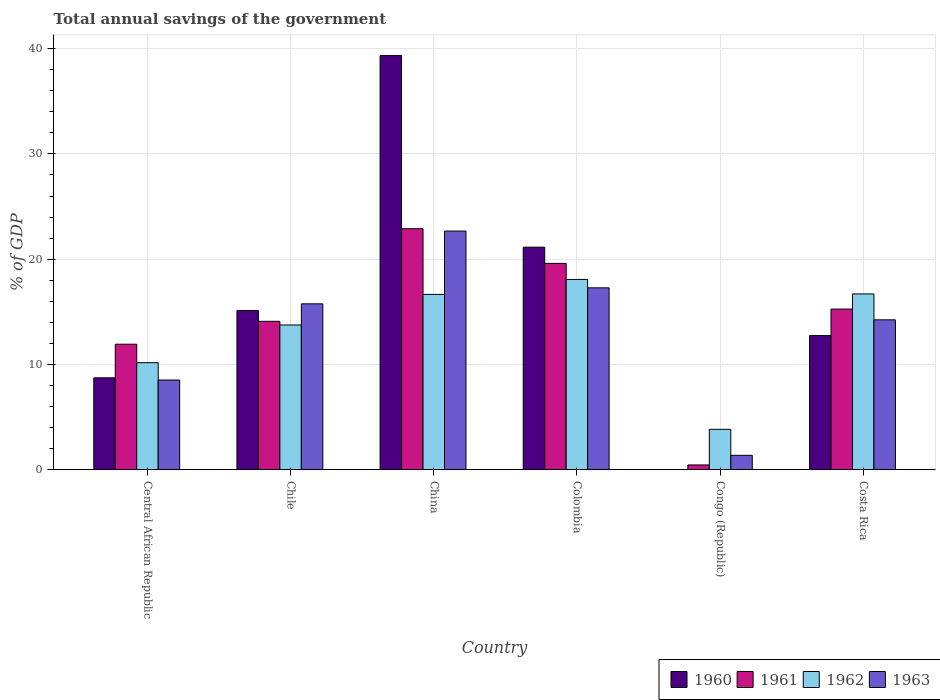How many different coloured bars are there?
Your answer should be compact. 4. How many groups of bars are there?
Your response must be concise. 6. Are the number of bars per tick equal to the number of legend labels?
Offer a terse response. No. How many bars are there on the 6th tick from the left?
Provide a succinct answer. 4. How many bars are there on the 3rd tick from the right?
Keep it short and to the point. 4. Across all countries, what is the maximum total annual savings of the government in 1961?
Keep it short and to the point. 22.89. Across all countries, what is the minimum total annual savings of the government in 1962?
Make the answer very short. 3.84. In which country was the total annual savings of the government in 1963 maximum?
Your response must be concise. China. What is the total total annual savings of the government in 1960 in the graph?
Keep it short and to the point. 97.07. What is the difference between the total annual savings of the government in 1962 in Colombia and that in Costa Rica?
Make the answer very short. 1.38. What is the difference between the total annual savings of the government in 1962 in Costa Rica and the total annual savings of the government in 1960 in Colombia?
Offer a terse response. -4.44. What is the average total annual savings of the government in 1961 per country?
Give a very brief answer. 14.04. What is the difference between the total annual savings of the government of/in 1963 and total annual savings of the government of/in 1961 in Central African Republic?
Give a very brief answer. -3.4. What is the ratio of the total annual savings of the government in 1963 in Central African Republic to that in Costa Rica?
Ensure brevity in your answer.  0.6. Is the difference between the total annual savings of the government in 1963 in Chile and Costa Rica greater than the difference between the total annual savings of the government in 1961 in Chile and Costa Rica?
Give a very brief answer. Yes. What is the difference between the highest and the second highest total annual savings of the government in 1962?
Offer a very short reply. 0.04. What is the difference between the highest and the lowest total annual savings of the government in 1963?
Make the answer very short. 21.3. In how many countries, is the total annual savings of the government in 1963 greater than the average total annual savings of the government in 1963 taken over all countries?
Your answer should be compact. 4. Is it the case that in every country, the sum of the total annual savings of the government in 1961 and total annual savings of the government in 1962 is greater than the total annual savings of the government in 1960?
Provide a succinct answer. Yes. How many countries are there in the graph?
Your answer should be compact. 6. What is the difference between two consecutive major ticks on the Y-axis?
Offer a very short reply. 10. How are the legend labels stacked?
Make the answer very short. Horizontal. What is the title of the graph?
Offer a very short reply. Total annual savings of the government. Does "2007" appear as one of the legend labels in the graph?
Provide a short and direct response. No. What is the label or title of the Y-axis?
Offer a very short reply. % of GDP. What is the % of GDP in 1960 in Central African Republic?
Provide a succinct answer. 8.73. What is the % of GDP in 1961 in Central African Republic?
Your answer should be very brief. 11.92. What is the % of GDP in 1962 in Central African Republic?
Offer a very short reply. 10.16. What is the % of GDP in 1963 in Central African Republic?
Your answer should be compact. 8.52. What is the % of GDP of 1960 in Chile?
Provide a succinct answer. 15.12. What is the % of GDP of 1961 in Chile?
Your answer should be very brief. 14.1. What is the % of GDP in 1962 in Chile?
Provide a succinct answer. 13.75. What is the % of GDP of 1963 in Chile?
Offer a terse response. 15.76. What is the % of GDP of 1960 in China?
Your answer should be very brief. 39.34. What is the % of GDP in 1961 in China?
Your answer should be very brief. 22.89. What is the % of GDP of 1962 in China?
Ensure brevity in your answer.  16.65. What is the % of GDP in 1963 in China?
Ensure brevity in your answer.  22.67. What is the % of GDP of 1960 in Colombia?
Make the answer very short. 21.14. What is the % of GDP in 1961 in Colombia?
Your answer should be very brief. 19.6. What is the % of GDP of 1962 in Colombia?
Offer a very short reply. 18.08. What is the % of GDP of 1963 in Colombia?
Offer a very short reply. 17.28. What is the % of GDP of 1961 in Congo (Republic)?
Make the answer very short. 0.45. What is the % of GDP of 1962 in Congo (Republic)?
Make the answer very short. 3.84. What is the % of GDP in 1963 in Congo (Republic)?
Offer a terse response. 1.37. What is the % of GDP in 1960 in Costa Rica?
Ensure brevity in your answer.  12.74. What is the % of GDP of 1961 in Costa Rica?
Provide a succinct answer. 15.26. What is the % of GDP of 1962 in Costa Rica?
Give a very brief answer. 16.7. What is the % of GDP of 1963 in Costa Rica?
Your answer should be very brief. 14.24. Across all countries, what is the maximum % of GDP in 1960?
Ensure brevity in your answer.  39.34. Across all countries, what is the maximum % of GDP of 1961?
Provide a short and direct response. 22.89. Across all countries, what is the maximum % of GDP of 1962?
Give a very brief answer. 18.08. Across all countries, what is the maximum % of GDP of 1963?
Keep it short and to the point. 22.67. Across all countries, what is the minimum % of GDP in 1961?
Give a very brief answer. 0.45. Across all countries, what is the minimum % of GDP of 1962?
Provide a short and direct response. 3.84. Across all countries, what is the minimum % of GDP of 1963?
Your response must be concise. 1.37. What is the total % of GDP of 1960 in the graph?
Your answer should be compact. 97.07. What is the total % of GDP of 1961 in the graph?
Offer a terse response. 84.22. What is the total % of GDP of 1962 in the graph?
Keep it short and to the point. 79.17. What is the total % of GDP of 1963 in the graph?
Provide a succinct answer. 79.83. What is the difference between the % of GDP in 1960 in Central African Republic and that in Chile?
Give a very brief answer. -6.39. What is the difference between the % of GDP of 1961 in Central African Republic and that in Chile?
Offer a very short reply. -2.18. What is the difference between the % of GDP of 1962 in Central African Republic and that in Chile?
Give a very brief answer. -3.58. What is the difference between the % of GDP in 1963 in Central African Republic and that in Chile?
Provide a short and direct response. -7.24. What is the difference between the % of GDP in 1960 in Central African Republic and that in China?
Give a very brief answer. -30.61. What is the difference between the % of GDP of 1961 in Central African Republic and that in China?
Provide a succinct answer. -10.97. What is the difference between the % of GDP of 1962 in Central African Republic and that in China?
Your answer should be compact. -6.49. What is the difference between the % of GDP of 1963 in Central African Republic and that in China?
Offer a terse response. -14.15. What is the difference between the % of GDP in 1960 in Central African Republic and that in Colombia?
Your response must be concise. -12.41. What is the difference between the % of GDP in 1961 in Central African Republic and that in Colombia?
Your response must be concise. -7.68. What is the difference between the % of GDP in 1962 in Central African Republic and that in Colombia?
Keep it short and to the point. -7.91. What is the difference between the % of GDP of 1963 in Central African Republic and that in Colombia?
Ensure brevity in your answer.  -8.76. What is the difference between the % of GDP of 1961 in Central African Republic and that in Congo (Republic)?
Your answer should be very brief. 11.47. What is the difference between the % of GDP in 1962 in Central African Republic and that in Congo (Republic)?
Provide a short and direct response. 6.33. What is the difference between the % of GDP in 1963 in Central African Republic and that in Congo (Republic)?
Offer a very short reply. 7.15. What is the difference between the % of GDP of 1960 in Central African Republic and that in Costa Rica?
Provide a succinct answer. -4.01. What is the difference between the % of GDP in 1961 in Central African Republic and that in Costa Rica?
Provide a short and direct response. -3.34. What is the difference between the % of GDP in 1962 in Central African Republic and that in Costa Rica?
Offer a terse response. -6.53. What is the difference between the % of GDP in 1963 in Central African Republic and that in Costa Rica?
Your response must be concise. -5.72. What is the difference between the % of GDP of 1960 in Chile and that in China?
Ensure brevity in your answer.  -24.22. What is the difference between the % of GDP in 1961 in Chile and that in China?
Provide a short and direct response. -8.8. What is the difference between the % of GDP in 1962 in Chile and that in China?
Offer a very short reply. -2.91. What is the difference between the % of GDP in 1963 in Chile and that in China?
Make the answer very short. -6.91. What is the difference between the % of GDP in 1960 in Chile and that in Colombia?
Your answer should be compact. -6.02. What is the difference between the % of GDP in 1961 in Chile and that in Colombia?
Provide a succinct answer. -5.5. What is the difference between the % of GDP of 1962 in Chile and that in Colombia?
Ensure brevity in your answer.  -4.33. What is the difference between the % of GDP of 1963 in Chile and that in Colombia?
Provide a short and direct response. -1.52. What is the difference between the % of GDP of 1961 in Chile and that in Congo (Republic)?
Your answer should be compact. 13.64. What is the difference between the % of GDP in 1962 in Chile and that in Congo (Republic)?
Provide a succinct answer. 9.91. What is the difference between the % of GDP of 1963 in Chile and that in Congo (Republic)?
Give a very brief answer. 14.39. What is the difference between the % of GDP of 1960 in Chile and that in Costa Rica?
Ensure brevity in your answer.  2.38. What is the difference between the % of GDP of 1961 in Chile and that in Costa Rica?
Make the answer very short. -1.16. What is the difference between the % of GDP in 1962 in Chile and that in Costa Rica?
Give a very brief answer. -2.95. What is the difference between the % of GDP of 1963 in Chile and that in Costa Rica?
Provide a succinct answer. 1.52. What is the difference between the % of GDP of 1960 in China and that in Colombia?
Make the answer very short. 18.2. What is the difference between the % of GDP of 1961 in China and that in Colombia?
Make the answer very short. 3.29. What is the difference between the % of GDP in 1962 in China and that in Colombia?
Your response must be concise. -1.42. What is the difference between the % of GDP in 1963 in China and that in Colombia?
Your response must be concise. 5.39. What is the difference between the % of GDP of 1961 in China and that in Congo (Republic)?
Offer a terse response. 22.44. What is the difference between the % of GDP in 1962 in China and that in Congo (Republic)?
Offer a terse response. 12.82. What is the difference between the % of GDP in 1963 in China and that in Congo (Republic)?
Provide a succinct answer. 21.3. What is the difference between the % of GDP of 1960 in China and that in Costa Rica?
Offer a very short reply. 26.6. What is the difference between the % of GDP of 1961 in China and that in Costa Rica?
Your answer should be very brief. 7.63. What is the difference between the % of GDP of 1962 in China and that in Costa Rica?
Ensure brevity in your answer.  -0.04. What is the difference between the % of GDP of 1963 in China and that in Costa Rica?
Keep it short and to the point. 8.43. What is the difference between the % of GDP in 1961 in Colombia and that in Congo (Republic)?
Offer a very short reply. 19.15. What is the difference between the % of GDP in 1962 in Colombia and that in Congo (Republic)?
Make the answer very short. 14.24. What is the difference between the % of GDP of 1963 in Colombia and that in Congo (Republic)?
Provide a short and direct response. 15.91. What is the difference between the % of GDP of 1960 in Colombia and that in Costa Rica?
Your answer should be compact. 8.4. What is the difference between the % of GDP of 1961 in Colombia and that in Costa Rica?
Offer a terse response. 4.34. What is the difference between the % of GDP in 1962 in Colombia and that in Costa Rica?
Provide a succinct answer. 1.38. What is the difference between the % of GDP of 1963 in Colombia and that in Costa Rica?
Provide a succinct answer. 3.04. What is the difference between the % of GDP in 1961 in Congo (Republic) and that in Costa Rica?
Provide a succinct answer. -14.81. What is the difference between the % of GDP in 1962 in Congo (Republic) and that in Costa Rica?
Your answer should be very brief. -12.86. What is the difference between the % of GDP of 1963 in Congo (Republic) and that in Costa Rica?
Provide a short and direct response. -12.87. What is the difference between the % of GDP of 1960 in Central African Republic and the % of GDP of 1961 in Chile?
Provide a succinct answer. -5.37. What is the difference between the % of GDP of 1960 in Central African Republic and the % of GDP of 1962 in Chile?
Offer a very short reply. -5.02. What is the difference between the % of GDP in 1960 in Central African Republic and the % of GDP in 1963 in Chile?
Your response must be concise. -7.03. What is the difference between the % of GDP of 1961 in Central African Republic and the % of GDP of 1962 in Chile?
Give a very brief answer. -1.83. What is the difference between the % of GDP in 1961 in Central African Republic and the % of GDP in 1963 in Chile?
Make the answer very short. -3.84. What is the difference between the % of GDP of 1962 in Central African Republic and the % of GDP of 1963 in Chile?
Offer a terse response. -5.59. What is the difference between the % of GDP in 1960 in Central African Republic and the % of GDP in 1961 in China?
Provide a short and direct response. -14.17. What is the difference between the % of GDP of 1960 in Central African Republic and the % of GDP of 1962 in China?
Provide a succinct answer. -7.93. What is the difference between the % of GDP of 1960 in Central African Republic and the % of GDP of 1963 in China?
Provide a short and direct response. -13.94. What is the difference between the % of GDP in 1961 in Central African Republic and the % of GDP in 1962 in China?
Your response must be concise. -4.73. What is the difference between the % of GDP of 1961 in Central African Republic and the % of GDP of 1963 in China?
Provide a succinct answer. -10.75. What is the difference between the % of GDP of 1962 in Central African Republic and the % of GDP of 1963 in China?
Make the answer very short. -12.51. What is the difference between the % of GDP in 1960 in Central African Republic and the % of GDP in 1961 in Colombia?
Your answer should be compact. -10.87. What is the difference between the % of GDP of 1960 in Central African Republic and the % of GDP of 1962 in Colombia?
Keep it short and to the point. -9.35. What is the difference between the % of GDP in 1960 in Central African Republic and the % of GDP in 1963 in Colombia?
Make the answer very short. -8.55. What is the difference between the % of GDP in 1961 in Central African Republic and the % of GDP in 1962 in Colombia?
Give a very brief answer. -6.15. What is the difference between the % of GDP in 1961 in Central African Republic and the % of GDP in 1963 in Colombia?
Offer a terse response. -5.36. What is the difference between the % of GDP in 1962 in Central African Republic and the % of GDP in 1963 in Colombia?
Provide a short and direct response. -7.11. What is the difference between the % of GDP of 1960 in Central African Republic and the % of GDP of 1961 in Congo (Republic)?
Offer a terse response. 8.28. What is the difference between the % of GDP of 1960 in Central African Republic and the % of GDP of 1962 in Congo (Republic)?
Provide a succinct answer. 4.89. What is the difference between the % of GDP in 1960 in Central African Republic and the % of GDP in 1963 in Congo (Republic)?
Your answer should be very brief. 7.36. What is the difference between the % of GDP of 1961 in Central African Republic and the % of GDP of 1962 in Congo (Republic)?
Keep it short and to the point. 8.08. What is the difference between the % of GDP of 1961 in Central African Republic and the % of GDP of 1963 in Congo (Republic)?
Your response must be concise. 10.55. What is the difference between the % of GDP in 1962 in Central African Republic and the % of GDP in 1963 in Congo (Republic)?
Offer a very short reply. 8.8. What is the difference between the % of GDP in 1960 in Central African Republic and the % of GDP in 1961 in Costa Rica?
Keep it short and to the point. -6.53. What is the difference between the % of GDP of 1960 in Central African Republic and the % of GDP of 1962 in Costa Rica?
Provide a short and direct response. -7.97. What is the difference between the % of GDP of 1960 in Central African Republic and the % of GDP of 1963 in Costa Rica?
Give a very brief answer. -5.51. What is the difference between the % of GDP in 1961 in Central African Republic and the % of GDP in 1962 in Costa Rica?
Ensure brevity in your answer.  -4.78. What is the difference between the % of GDP of 1961 in Central African Republic and the % of GDP of 1963 in Costa Rica?
Offer a terse response. -2.32. What is the difference between the % of GDP in 1962 in Central African Republic and the % of GDP in 1963 in Costa Rica?
Offer a terse response. -4.07. What is the difference between the % of GDP of 1960 in Chile and the % of GDP of 1961 in China?
Keep it short and to the point. -7.77. What is the difference between the % of GDP of 1960 in Chile and the % of GDP of 1962 in China?
Keep it short and to the point. -1.53. What is the difference between the % of GDP in 1960 in Chile and the % of GDP in 1963 in China?
Offer a terse response. -7.55. What is the difference between the % of GDP of 1961 in Chile and the % of GDP of 1962 in China?
Your answer should be very brief. -2.56. What is the difference between the % of GDP of 1961 in Chile and the % of GDP of 1963 in China?
Your response must be concise. -8.57. What is the difference between the % of GDP in 1962 in Chile and the % of GDP in 1963 in China?
Your answer should be very brief. -8.92. What is the difference between the % of GDP in 1960 in Chile and the % of GDP in 1961 in Colombia?
Give a very brief answer. -4.48. What is the difference between the % of GDP in 1960 in Chile and the % of GDP in 1962 in Colombia?
Make the answer very short. -2.96. What is the difference between the % of GDP in 1960 in Chile and the % of GDP in 1963 in Colombia?
Your answer should be compact. -2.16. What is the difference between the % of GDP in 1961 in Chile and the % of GDP in 1962 in Colombia?
Provide a succinct answer. -3.98. What is the difference between the % of GDP of 1961 in Chile and the % of GDP of 1963 in Colombia?
Offer a very short reply. -3.18. What is the difference between the % of GDP of 1962 in Chile and the % of GDP of 1963 in Colombia?
Provide a short and direct response. -3.53. What is the difference between the % of GDP in 1960 in Chile and the % of GDP in 1961 in Congo (Republic)?
Keep it short and to the point. 14.67. What is the difference between the % of GDP in 1960 in Chile and the % of GDP in 1962 in Congo (Republic)?
Provide a short and direct response. 11.28. What is the difference between the % of GDP in 1960 in Chile and the % of GDP in 1963 in Congo (Republic)?
Offer a very short reply. 13.75. What is the difference between the % of GDP of 1961 in Chile and the % of GDP of 1962 in Congo (Republic)?
Your response must be concise. 10.26. What is the difference between the % of GDP in 1961 in Chile and the % of GDP in 1963 in Congo (Republic)?
Ensure brevity in your answer.  12.73. What is the difference between the % of GDP of 1962 in Chile and the % of GDP of 1963 in Congo (Republic)?
Keep it short and to the point. 12.38. What is the difference between the % of GDP of 1960 in Chile and the % of GDP of 1961 in Costa Rica?
Give a very brief answer. -0.14. What is the difference between the % of GDP of 1960 in Chile and the % of GDP of 1962 in Costa Rica?
Your response must be concise. -1.58. What is the difference between the % of GDP of 1960 in Chile and the % of GDP of 1963 in Costa Rica?
Give a very brief answer. 0.88. What is the difference between the % of GDP in 1961 in Chile and the % of GDP in 1962 in Costa Rica?
Your answer should be very brief. -2.6. What is the difference between the % of GDP in 1961 in Chile and the % of GDP in 1963 in Costa Rica?
Make the answer very short. -0.14. What is the difference between the % of GDP in 1962 in Chile and the % of GDP in 1963 in Costa Rica?
Keep it short and to the point. -0.49. What is the difference between the % of GDP in 1960 in China and the % of GDP in 1961 in Colombia?
Your response must be concise. 19.74. What is the difference between the % of GDP in 1960 in China and the % of GDP in 1962 in Colombia?
Provide a succinct answer. 21.27. What is the difference between the % of GDP in 1960 in China and the % of GDP in 1963 in Colombia?
Give a very brief answer. 22.06. What is the difference between the % of GDP in 1961 in China and the % of GDP in 1962 in Colombia?
Give a very brief answer. 4.82. What is the difference between the % of GDP in 1961 in China and the % of GDP in 1963 in Colombia?
Keep it short and to the point. 5.62. What is the difference between the % of GDP of 1962 in China and the % of GDP of 1963 in Colombia?
Provide a short and direct response. -0.62. What is the difference between the % of GDP in 1960 in China and the % of GDP in 1961 in Congo (Republic)?
Keep it short and to the point. 38.89. What is the difference between the % of GDP of 1960 in China and the % of GDP of 1962 in Congo (Republic)?
Ensure brevity in your answer.  35.5. What is the difference between the % of GDP in 1960 in China and the % of GDP in 1963 in Congo (Republic)?
Keep it short and to the point. 37.97. What is the difference between the % of GDP of 1961 in China and the % of GDP of 1962 in Congo (Republic)?
Ensure brevity in your answer.  19.06. What is the difference between the % of GDP in 1961 in China and the % of GDP in 1963 in Congo (Republic)?
Your answer should be very brief. 21.53. What is the difference between the % of GDP in 1962 in China and the % of GDP in 1963 in Congo (Republic)?
Provide a succinct answer. 15.29. What is the difference between the % of GDP in 1960 in China and the % of GDP in 1961 in Costa Rica?
Offer a terse response. 24.08. What is the difference between the % of GDP in 1960 in China and the % of GDP in 1962 in Costa Rica?
Provide a succinct answer. 22.64. What is the difference between the % of GDP in 1960 in China and the % of GDP in 1963 in Costa Rica?
Provide a succinct answer. 25.1. What is the difference between the % of GDP of 1961 in China and the % of GDP of 1962 in Costa Rica?
Offer a terse response. 6.2. What is the difference between the % of GDP in 1961 in China and the % of GDP in 1963 in Costa Rica?
Your response must be concise. 8.66. What is the difference between the % of GDP of 1962 in China and the % of GDP of 1963 in Costa Rica?
Offer a very short reply. 2.42. What is the difference between the % of GDP of 1960 in Colombia and the % of GDP of 1961 in Congo (Republic)?
Your response must be concise. 20.69. What is the difference between the % of GDP of 1960 in Colombia and the % of GDP of 1962 in Congo (Republic)?
Ensure brevity in your answer.  17.3. What is the difference between the % of GDP in 1960 in Colombia and the % of GDP in 1963 in Congo (Republic)?
Your response must be concise. 19.77. What is the difference between the % of GDP of 1961 in Colombia and the % of GDP of 1962 in Congo (Republic)?
Your answer should be compact. 15.76. What is the difference between the % of GDP in 1961 in Colombia and the % of GDP in 1963 in Congo (Republic)?
Give a very brief answer. 18.23. What is the difference between the % of GDP of 1962 in Colombia and the % of GDP of 1963 in Congo (Republic)?
Provide a short and direct response. 16.71. What is the difference between the % of GDP in 1960 in Colombia and the % of GDP in 1961 in Costa Rica?
Offer a terse response. 5.88. What is the difference between the % of GDP of 1960 in Colombia and the % of GDP of 1962 in Costa Rica?
Your answer should be very brief. 4.44. What is the difference between the % of GDP in 1960 in Colombia and the % of GDP in 1963 in Costa Rica?
Your answer should be very brief. 6.9. What is the difference between the % of GDP in 1961 in Colombia and the % of GDP in 1962 in Costa Rica?
Keep it short and to the point. 2.9. What is the difference between the % of GDP of 1961 in Colombia and the % of GDP of 1963 in Costa Rica?
Keep it short and to the point. 5.36. What is the difference between the % of GDP of 1962 in Colombia and the % of GDP of 1963 in Costa Rica?
Your response must be concise. 3.84. What is the difference between the % of GDP of 1961 in Congo (Republic) and the % of GDP of 1962 in Costa Rica?
Give a very brief answer. -16.25. What is the difference between the % of GDP of 1961 in Congo (Republic) and the % of GDP of 1963 in Costa Rica?
Offer a very short reply. -13.79. What is the difference between the % of GDP in 1962 in Congo (Republic) and the % of GDP in 1963 in Costa Rica?
Make the answer very short. -10.4. What is the average % of GDP in 1960 per country?
Give a very brief answer. 16.18. What is the average % of GDP of 1961 per country?
Offer a very short reply. 14.04. What is the average % of GDP in 1962 per country?
Your answer should be very brief. 13.2. What is the average % of GDP of 1963 per country?
Provide a short and direct response. 13.3. What is the difference between the % of GDP in 1960 and % of GDP in 1961 in Central African Republic?
Offer a terse response. -3.19. What is the difference between the % of GDP in 1960 and % of GDP in 1962 in Central African Republic?
Provide a short and direct response. -1.44. What is the difference between the % of GDP of 1960 and % of GDP of 1963 in Central African Republic?
Give a very brief answer. 0.21. What is the difference between the % of GDP in 1961 and % of GDP in 1962 in Central African Republic?
Keep it short and to the point. 1.76. What is the difference between the % of GDP in 1961 and % of GDP in 1963 in Central African Republic?
Make the answer very short. 3.4. What is the difference between the % of GDP of 1962 and % of GDP of 1963 in Central African Republic?
Provide a short and direct response. 1.65. What is the difference between the % of GDP of 1960 and % of GDP of 1961 in Chile?
Provide a succinct answer. 1.02. What is the difference between the % of GDP of 1960 and % of GDP of 1962 in Chile?
Keep it short and to the point. 1.37. What is the difference between the % of GDP in 1960 and % of GDP in 1963 in Chile?
Make the answer very short. -0.64. What is the difference between the % of GDP in 1961 and % of GDP in 1962 in Chile?
Your response must be concise. 0.35. What is the difference between the % of GDP in 1961 and % of GDP in 1963 in Chile?
Ensure brevity in your answer.  -1.66. What is the difference between the % of GDP of 1962 and % of GDP of 1963 in Chile?
Offer a terse response. -2.01. What is the difference between the % of GDP in 1960 and % of GDP in 1961 in China?
Give a very brief answer. 16.45. What is the difference between the % of GDP of 1960 and % of GDP of 1962 in China?
Offer a terse response. 22.69. What is the difference between the % of GDP in 1960 and % of GDP in 1963 in China?
Offer a terse response. 16.67. What is the difference between the % of GDP of 1961 and % of GDP of 1962 in China?
Provide a short and direct response. 6.24. What is the difference between the % of GDP in 1961 and % of GDP in 1963 in China?
Make the answer very short. 0.22. What is the difference between the % of GDP in 1962 and % of GDP in 1963 in China?
Offer a very short reply. -6.02. What is the difference between the % of GDP in 1960 and % of GDP in 1961 in Colombia?
Keep it short and to the point. 1.54. What is the difference between the % of GDP in 1960 and % of GDP in 1962 in Colombia?
Your answer should be compact. 3.07. What is the difference between the % of GDP in 1960 and % of GDP in 1963 in Colombia?
Provide a short and direct response. 3.86. What is the difference between the % of GDP in 1961 and % of GDP in 1962 in Colombia?
Offer a very short reply. 1.53. What is the difference between the % of GDP of 1961 and % of GDP of 1963 in Colombia?
Offer a terse response. 2.32. What is the difference between the % of GDP in 1962 and % of GDP in 1963 in Colombia?
Keep it short and to the point. 0.8. What is the difference between the % of GDP in 1961 and % of GDP in 1962 in Congo (Republic)?
Ensure brevity in your answer.  -3.38. What is the difference between the % of GDP in 1961 and % of GDP in 1963 in Congo (Republic)?
Your answer should be compact. -0.91. What is the difference between the % of GDP of 1962 and % of GDP of 1963 in Congo (Republic)?
Provide a succinct answer. 2.47. What is the difference between the % of GDP in 1960 and % of GDP in 1961 in Costa Rica?
Offer a terse response. -2.52. What is the difference between the % of GDP of 1960 and % of GDP of 1962 in Costa Rica?
Offer a very short reply. -3.96. What is the difference between the % of GDP of 1960 and % of GDP of 1963 in Costa Rica?
Keep it short and to the point. -1.5. What is the difference between the % of GDP in 1961 and % of GDP in 1962 in Costa Rica?
Keep it short and to the point. -1.44. What is the difference between the % of GDP of 1961 and % of GDP of 1963 in Costa Rica?
Provide a succinct answer. 1.02. What is the difference between the % of GDP in 1962 and % of GDP in 1963 in Costa Rica?
Your response must be concise. 2.46. What is the ratio of the % of GDP in 1960 in Central African Republic to that in Chile?
Offer a terse response. 0.58. What is the ratio of the % of GDP in 1961 in Central African Republic to that in Chile?
Offer a very short reply. 0.85. What is the ratio of the % of GDP of 1962 in Central African Republic to that in Chile?
Give a very brief answer. 0.74. What is the ratio of the % of GDP in 1963 in Central African Republic to that in Chile?
Provide a short and direct response. 0.54. What is the ratio of the % of GDP in 1960 in Central African Republic to that in China?
Offer a very short reply. 0.22. What is the ratio of the % of GDP of 1961 in Central African Republic to that in China?
Offer a very short reply. 0.52. What is the ratio of the % of GDP in 1962 in Central African Republic to that in China?
Keep it short and to the point. 0.61. What is the ratio of the % of GDP of 1963 in Central African Republic to that in China?
Make the answer very short. 0.38. What is the ratio of the % of GDP of 1960 in Central African Republic to that in Colombia?
Your answer should be very brief. 0.41. What is the ratio of the % of GDP in 1961 in Central African Republic to that in Colombia?
Make the answer very short. 0.61. What is the ratio of the % of GDP of 1962 in Central African Republic to that in Colombia?
Offer a terse response. 0.56. What is the ratio of the % of GDP of 1963 in Central African Republic to that in Colombia?
Your answer should be very brief. 0.49. What is the ratio of the % of GDP in 1961 in Central African Republic to that in Congo (Republic)?
Ensure brevity in your answer.  26.38. What is the ratio of the % of GDP in 1962 in Central African Republic to that in Congo (Republic)?
Your answer should be compact. 2.65. What is the ratio of the % of GDP of 1963 in Central African Republic to that in Congo (Republic)?
Your answer should be very brief. 6.23. What is the ratio of the % of GDP in 1960 in Central African Republic to that in Costa Rica?
Make the answer very short. 0.69. What is the ratio of the % of GDP in 1961 in Central African Republic to that in Costa Rica?
Your response must be concise. 0.78. What is the ratio of the % of GDP of 1962 in Central African Republic to that in Costa Rica?
Provide a succinct answer. 0.61. What is the ratio of the % of GDP in 1963 in Central African Republic to that in Costa Rica?
Your answer should be very brief. 0.6. What is the ratio of the % of GDP in 1960 in Chile to that in China?
Provide a short and direct response. 0.38. What is the ratio of the % of GDP of 1961 in Chile to that in China?
Provide a short and direct response. 0.62. What is the ratio of the % of GDP of 1962 in Chile to that in China?
Keep it short and to the point. 0.83. What is the ratio of the % of GDP in 1963 in Chile to that in China?
Make the answer very short. 0.69. What is the ratio of the % of GDP in 1960 in Chile to that in Colombia?
Your answer should be compact. 0.72. What is the ratio of the % of GDP of 1961 in Chile to that in Colombia?
Your answer should be compact. 0.72. What is the ratio of the % of GDP of 1962 in Chile to that in Colombia?
Provide a short and direct response. 0.76. What is the ratio of the % of GDP of 1963 in Chile to that in Colombia?
Keep it short and to the point. 0.91. What is the ratio of the % of GDP in 1961 in Chile to that in Congo (Republic)?
Your answer should be very brief. 31.2. What is the ratio of the % of GDP in 1962 in Chile to that in Congo (Republic)?
Give a very brief answer. 3.58. What is the ratio of the % of GDP in 1963 in Chile to that in Congo (Republic)?
Keep it short and to the point. 11.53. What is the ratio of the % of GDP in 1960 in Chile to that in Costa Rica?
Your response must be concise. 1.19. What is the ratio of the % of GDP of 1961 in Chile to that in Costa Rica?
Keep it short and to the point. 0.92. What is the ratio of the % of GDP in 1962 in Chile to that in Costa Rica?
Your answer should be very brief. 0.82. What is the ratio of the % of GDP in 1963 in Chile to that in Costa Rica?
Offer a terse response. 1.11. What is the ratio of the % of GDP in 1960 in China to that in Colombia?
Offer a terse response. 1.86. What is the ratio of the % of GDP of 1961 in China to that in Colombia?
Offer a very short reply. 1.17. What is the ratio of the % of GDP of 1962 in China to that in Colombia?
Ensure brevity in your answer.  0.92. What is the ratio of the % of GDP in 1963 in China to that in Colombia?
Offer a very short reply. 1.31. What is the ratio of the % of GDP in 1961 in China to that in Congo (Republic)?
Keep it short and to the point. 50.67. What is the ratio of the % of GDP in 1962 in China to that in Congo (Republic)?
Offer a very short reply. 4.34. What is the ratio of the % of GDP of 1963 in China to that in Congo (Republic)?
Your response must be concise. 16.59. What is the ratio of the % of GDP in 1960 in China to that in Costa Rica?
Give a very brief answer. 3.09. What is the ratio of the % of GDP of 1961 in China to that in Costa Rica?
Offer a very short reply. 1.5. What is the ratio of the % of GDP of 1963 in China to that in Costa Rica?
Your response must be concise. 1.59. What is the ratio of the % of GDP in 1961 in Colombia to that in Congo (Republic)?
Keep it short and to the point. 43.38. What is the ratio of the % of GDP in 1962 in Colombia to that in Congo (Republic)?
Your answer should be compact. 4.71. What is the ratio of the % of GDP in 1963 in Colombia to that in Congo (Republic)?
Your answer should be compact. 12.64. What is the ratio of the % of GDP in 1960 in Colombia to that in Costa Rica?
Your answer should be very brief. 1.66. What is the ratio of the % of GDP of 1961 in Colombia to that in Costa Rica?
Give a very brief answer. 1.28. What is the ratio of the % of GDP in 1962 in Colombia to that in Costa Rica?
Your answer should be very brief. 1.08. What is the ratio of the % of GDP of 1963 in Colombia to that in Costa Rica?
Offer a very short reply. 1.21. What is the ratio of the % of GDP of 1961 in Congo (Republic) to that in Costa Rica?
Provide a short and direct response. 0.03. What is the ratio of the % of GDP of 1962 in Congo (Republic) to that in Costa Rica?
Provide a succinct answer. 0.23. What is the ratio of the % of GDP of 1963 in Congo (Republic) to that in Costa Rica?
Ensure brevity in your answer.  0.1. What is the difference between the highest and the second highest % of GDP of 1960?
Make the answer very short. 18.2. What is the difference between the highest and the second highest % of GDP of 1961?
Ensure brevity in your answer.  3.29. What is the difference between the highest and the second highest % of GDP of 1962?
Offer a very short reply. 1.38. What is the difference between the highest and the second highest % of GDP of 1963?
Ensure brevity in your answer.  5.39. What is the difference between the highest and the lowest % of GDP of 1960?
Offer a terse response. 39.34. What is the difference between the highest and the lowest % of GDP in 1961?
Offer a very short reply. 22.44. What is the difference between the highest and the lowest % of GDP in 1962?
Give a very brief answer. 14.24. What is the difference between the highest and the lowest % of GDP in 1963?
Provide a succinct answer. 21.3. 